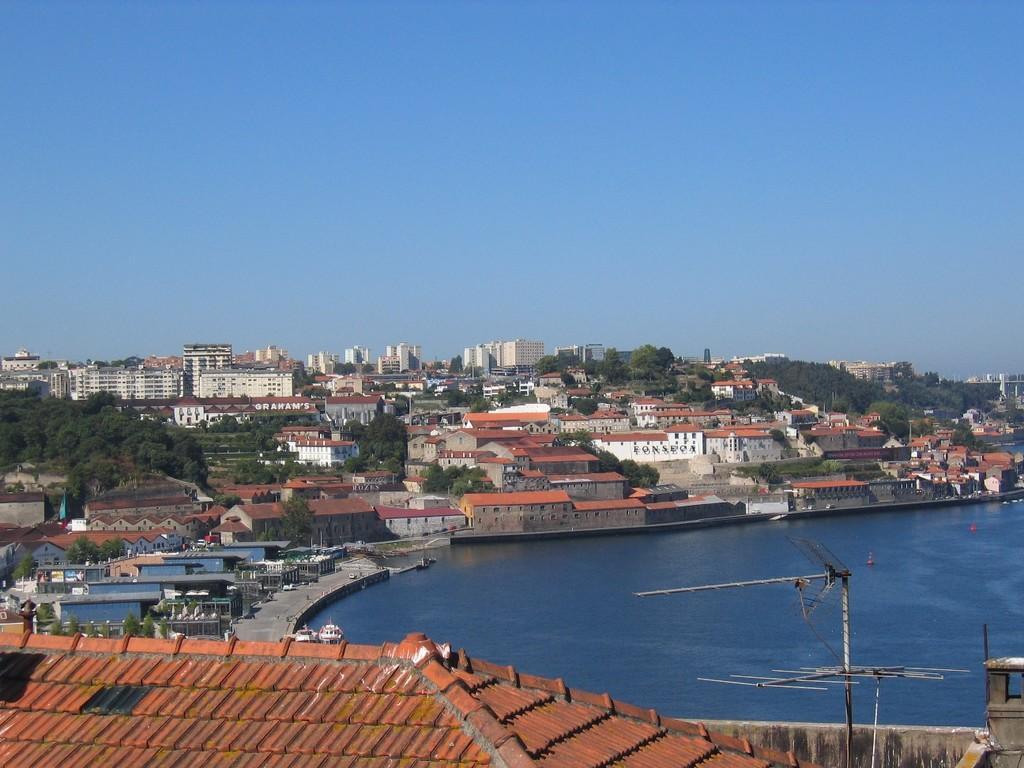Please provide a concise description of this image. In this image I can see few buildings, windows, trees, poles and few boats on water surface. I can see the sky. 